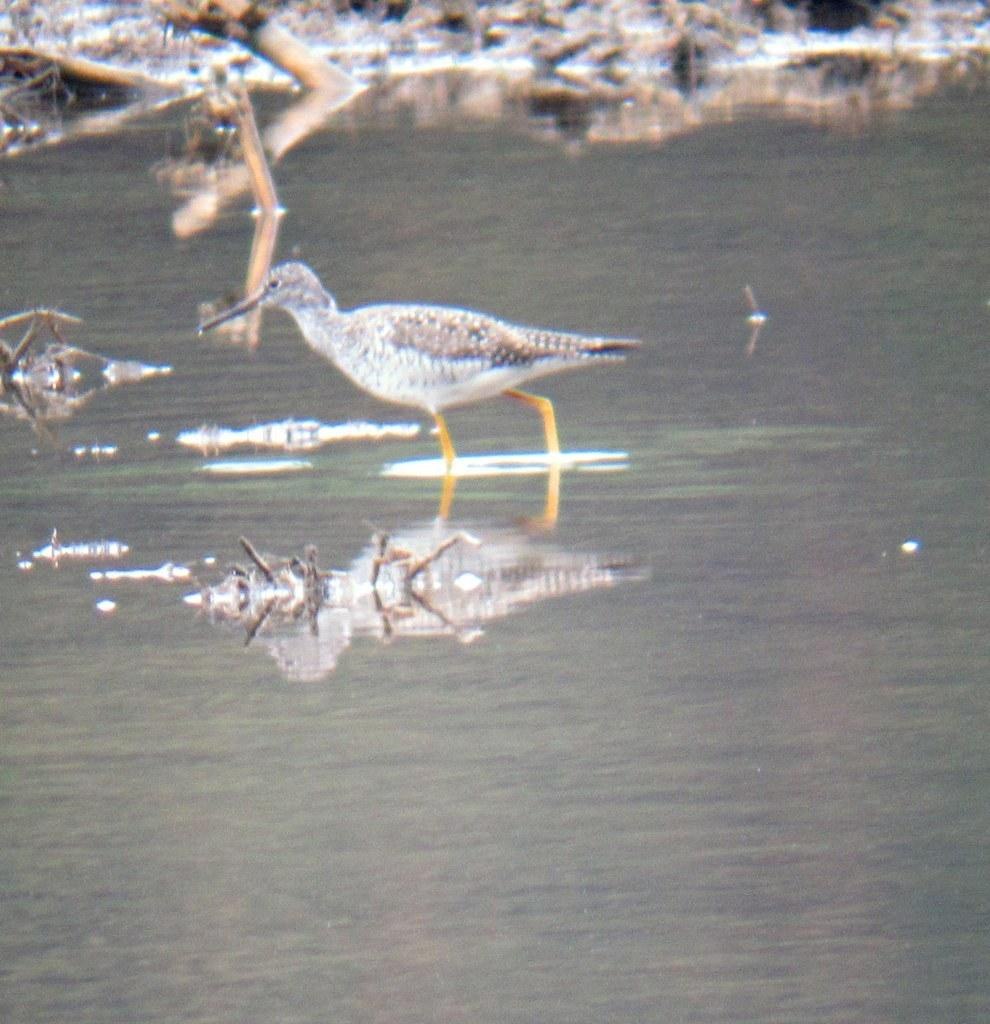What is located in the water in the image? There is a bird in the water in the image. What can be seen at the top of the image? There are small plants at the top of the image. What type of straw is being used by the organization in the image? There is no straw or organization present in the image; it features a bird in the water and small plants at the top. 